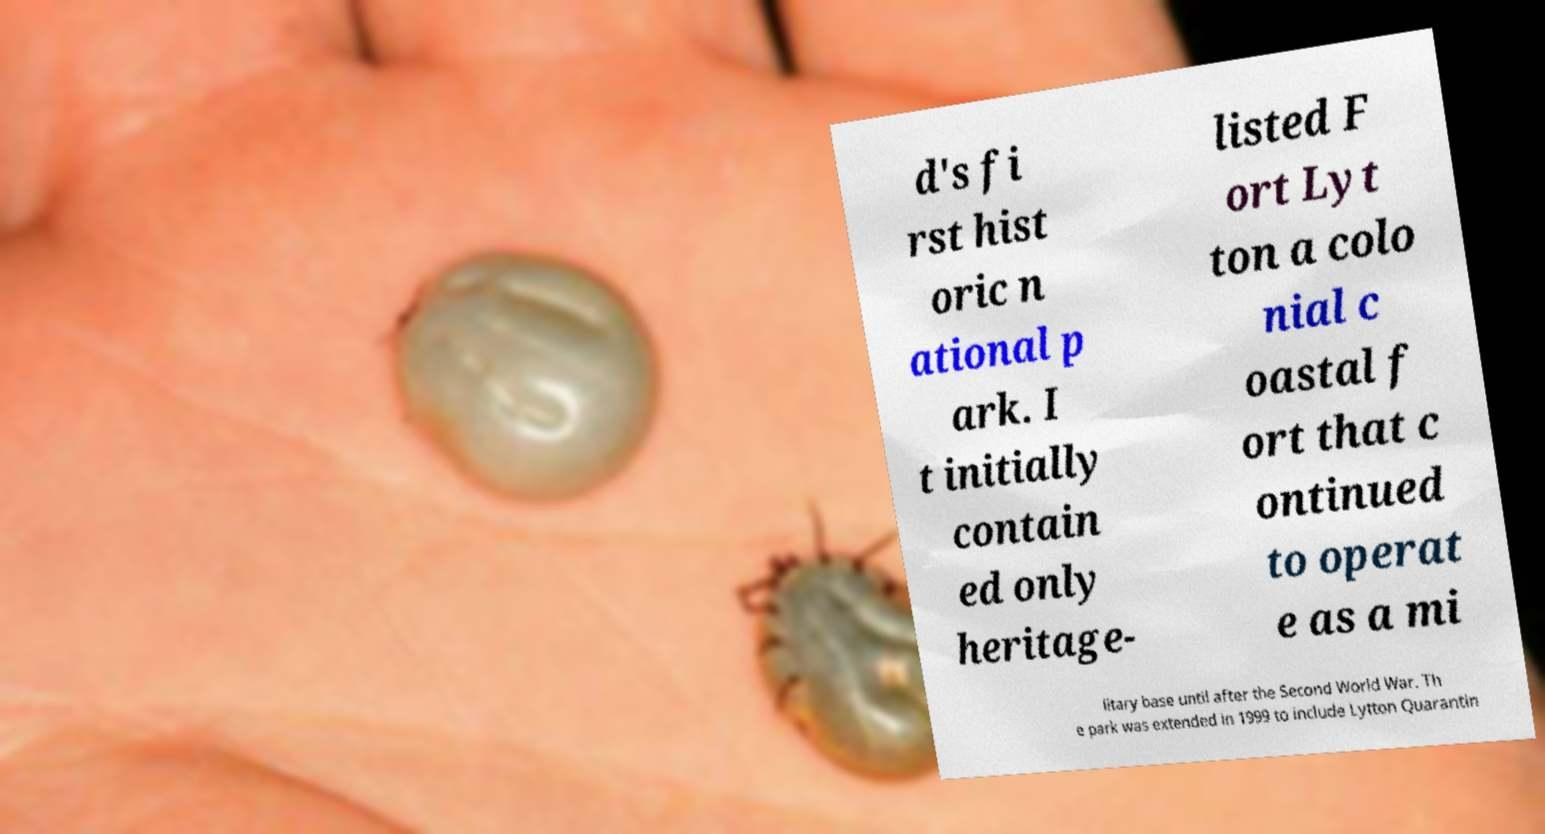Can you read and provide the text displayed in the image?This photo seems to have some interesting text. Can you extract and type it out for me? d's fi rst hist oric n ational p ark. I t initially contain ed only heritage- listed F ort Lyt ton a colo nial c oastal f ort that c ontinued to operat e as a mi litary base until after the Second World War. Th e park was extended in 1999 to include Lytton Quarantin 